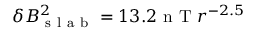Convert formula to latex. <formula><loc_0><loc_0><loc_500><loc_500>\delta B _ { s l a b } ^ { 2 } = 1 3 . 2 n T r ^ { - 2 . 5 }</formula> 